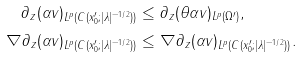Convert formula to latex. <formula><loc_0><loc_0><loc_500><loc_500>\| \partial _ { z } ( \alpha v ) \| _ { L ^ { p } ( C ( x _ { 0 } ^ { \prime } ; | \lambda | ^ { - 1 / 2 } ) ) } & \leq \| \partial _ { z } ( \theta \alpha v ) \| _ { L ^ { p } ( \Omega ^ { \prime } ) } , \\ \| \nabla \partial _ { z } ( \alpha v ) \| _ { L ^ { p } ( C ( x _ { 0 } ^ { \prime } ; | \lambda | ^ { - 1 / 2 } ) ) } & \leq \| \nabla \partial _ { z } ( \alpha v ) \| _ { L ^ { p } ( C ( x _ { 0 } ^ { \prime } ; | \lambda | ^ { - 1 / 2 } ) ) } .</formula> 